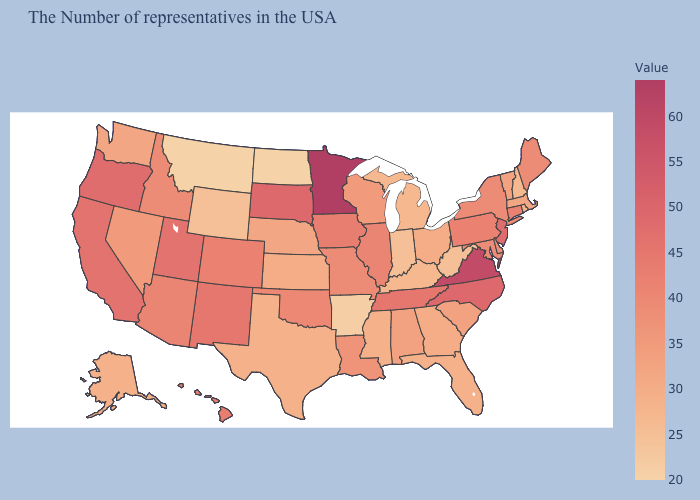Which states have the lowest value in the USA?
Give a very brief answer. North Dakota, Montana. Does Arizona have a lower value than Minnesota?
Quick response, please. Yes. Does the map have missing data?
Answer briefly. No. Does Connecticut have a lower value than Minnesota?
Be succinct. Yes. Which states have the lowest value in the South?
Be succinct. Arkansas. 